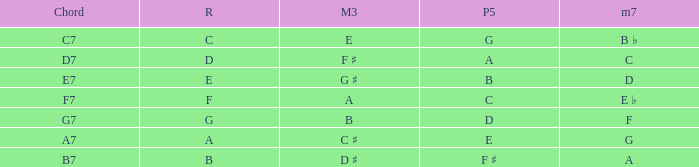Help me parse the entirety of this table. {'header': ['Chord', 'R', 'M3', 'P5', 'm7'], 'rows': [['C7', 'C', 'E', 'G', 'B ♭'], ['D7', 'D', 'F ♯', 'A', 'C'], ['E7', 'E', 'G ♯', 'B', 'D'], ['F7', 'F', 'A', 'C', 'E ♭'], ['G7', 'G', 'B', 'D', 'F'], ['A7', 'A', 'C ♯', 'E', 'G'], ['B7', 'B', 'D ♯', 'F ♯', 'A']]} What is the Perfect fifth with a Minor that is seventh of d? B. 